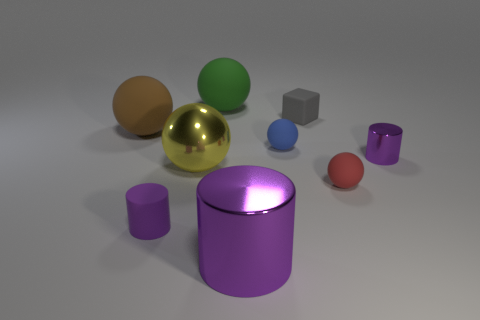Subtract 1 balls. How many balls are left? 4 Subtract all red balls. How many balls are left? 4 Subtract all brown spheres. How many spheres are left? 4 Subtract all cyan spheres. Subtract all gray blocks. How many spheres are left? 5 Add 1 big gray matte blocks. How many objects exist? 10 Subtract all blocks. How many objects are left? 8 Add 4 red rubber balls. How many red rubber balls exist? 5 Subtract 0 green cubes. How many objects are left? 9 Subtract all small cyan rubber cubes. Subtract all small red matte spheres. How many objects are left? 8 Add 7 brown things. How many brown things are left? 8 